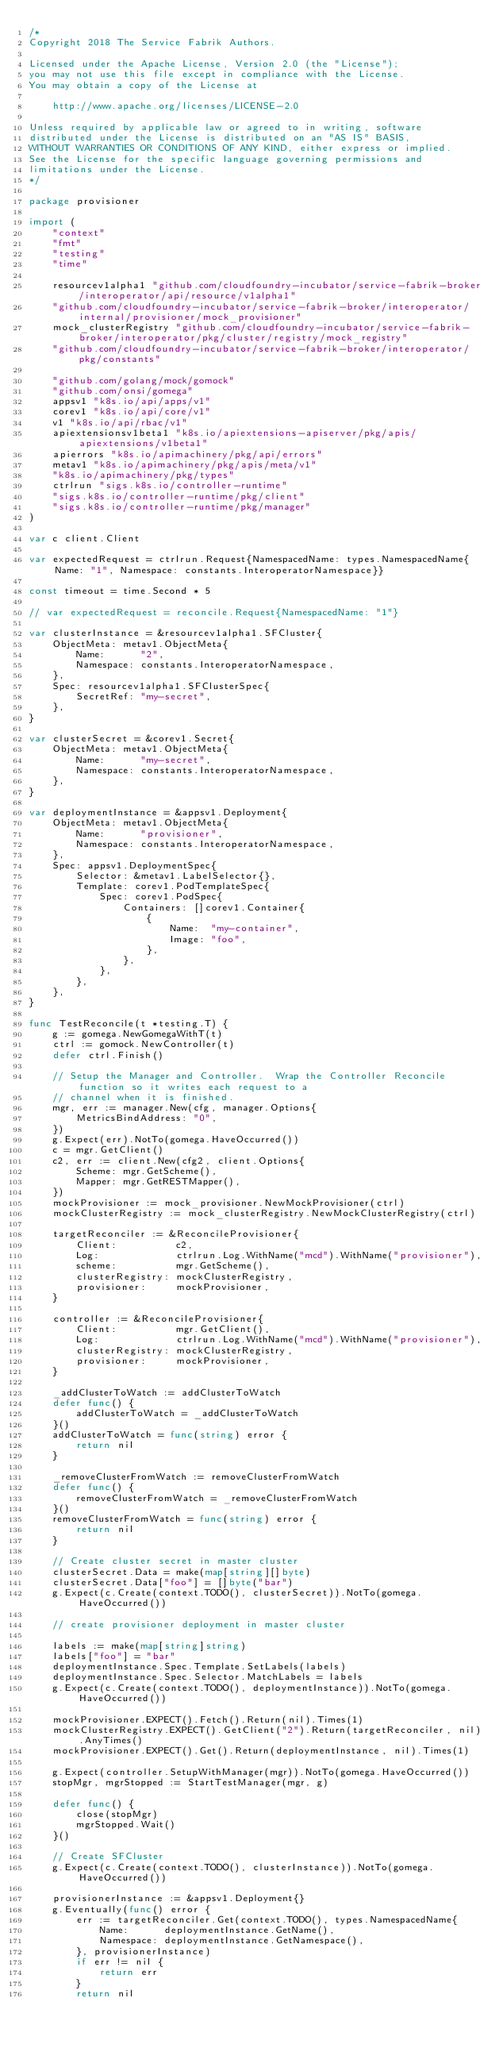<code> <loc_0><loc_0><loc_500><loc_500><_Go_>/*
Copyright 2018 The Service Fabrik Authors.

Licensed under the Apache License, Version 2.0 (the "License");
you may not use this file except in compliance with the License.
You may obtain a copy of the License at

    http://www.apache.org/licenses/LICENSE-2.0

Unless required by applicable law or agreed to in writing, software
distributed under the License is distributed on an "AS IS" BASIS,
WITHOUT WARRANTIES OR CONDITIONS OF ANY KIND, either express or implied.
See the License for the specific language governing permissions and
limitations under the License.
*/

package provisioner

import (
	"context"
	"fmt"
	"testing"
	"time"

	resourcev1alpha1 "github.com/cloudfoundry-incubator/service-fabrik-broker/interoperator/api/resource/v1alpha1"
	"github.com/cloudfoundry-incubator/service-fabrik-broker/interoperator/internal/provisioner/mock_provisioner"
	mock_clusterRegistry "github.com/cloudfoundry-incubator/service-fabrik-broker/interoperator/pkg/cluster/registry/mock_registry"
	"github.com/cloudfoundry-incubator/service-fabrik-broker/interoperator/pkg/constants"

	"github.com/golang/mock/gomock"
	"github.com/onsi/gomega"
	appsv1 "k8s.io/api/apps/v1"
	corev1 "k8s.io/api/core/v1"
	v1 "k8s.io/api/rbac/v1"
	apiextensionsv1beta1 "k8s.io/apiextensions-apiserver/pkg/apis/apiextensions/v1beta1"
	apierrors "k8s.io/apimachinery/pkg/api/errors"
	metav1 "k8s.io/apimachinery/pkg/apis/meta/v1"
	"k8s.io/apimachinery/pkg/types"
	ctrlrun "sigs.k8s.io/controller-runtime"
	"sigs.k8s.io/controller-runtime/pkg/client"
	"sigs.k8s.io/controller-runtime/pkg/manager"
)

var c client.Client

var expectedRequest = ctrlrun.Request{NamespacedName: types.NamespacedName{Name: "1", Namespace: constants.InteroperatorNamespace}}

const timeout = time.Second * 5

// var expectedRequest = reconcile.Request{NamespacedName: "1"}

var clusterInstance = &resourcev1alpha1.SFCluster{
	ObjectMeta: metav1.ObjectMeta{
		Name:      "2",
		Namespace: constants.InteroperatorNamespace,
	},
	Spec: resourcev1alpha1.SFClusterSpec{
		SecretRef: "my-secret",
	},
}

var clusterSecret = &corev1.Secret{
	ObjectMeta: metav1.ObjectMeta{
		Name:      "my-secret",
		Namespace: constants.InteroperatorNamespace,
	},
}

var deploymentInstance = &appsv1.Deployment{
	ObjectMeta: metav1.ObjectMeta{
		Name:      "provisioner",
		Namespace: constants.InteroperatorNamespace,
	},
	Spec: appsv1.DeploymentSpec{
		Selector: &metav1.LabelSelector{},
		Template: corev1.PodTemplateSpec{
			Spec: corev1.PodSpec{
				Containers: []corev1.Container{
					{
						Name:  "my-container",
						Image: "foo",
					},
				},
			},
		},
	},
}

func TestReconcile(t *testing.T) {
	g := gomega.NewGomegaWithT(t)
	ctrl := gomock.NewController(t)
	defer ctrl.Finish()

	// Setup the Manager and Controller.  Wrap the Controller Reconcile function so it writes each request to a
	// channel when it is finished.
	mgr, err := manager.New(cfg, manager.Options{
		MetricsBindAddress: "0",
	})
	g.Expect(err).NotTo(gomega.HaveOccurred())
	c = mgr.GetClient()
	c2, err := client.New(cfg2, client.Options{
		Scheme: mgr.GetScheme(),
		Mapper: mgr.GetRESTMapper(),
	})
	mockProvisioner := mock_provisioner.NewMockProvisioner(ctrl)
	mockClusterRegistry := mock_clusterRegistry.NewMockClusterRegistry(ctrl)

	targetReconciler := &ReconcileProvisioner{
		Client:          c2,
		Log:             ctrlrun.Log.WithName("mcd").WithName("provisioner"),
		scheme:          mgr.GetScheme(),
		clusterRegistry: mockClusterRegistry,
		provisioner:     mockProvisioner,
	}

	controller := &ReconcileProvisioner{
		Client:          mgr.GetClient(),
		Log:             ctrlrun.Log.WithName("mcd").WithName("provisioner"),
		clusterRegistry: mockClusterRegistry,
		provisioner:     mockProvisioner,
	}

	_addClusterToWatch := addClusterToWatch
	defer func() {
		addClusterToWatch = _addClusterToWatch
	}()
	addClusterToWatch = func(string) error {
		return nil
	}

	_removeClusterFromWatch := removeClusterFromWatch
	defer func() {
		removeClusterFromWatch = _removeClusterFromWatch
	}()
	removeClusterFromWatch = func(string) error {
		return nil
	}

	// Create cluster secret in master cluster
	clusterSecret.Data = make(map[string][]byte)
	clusterSecret.Data["foo"] = []byte("bar")
	g.Expect(c.Create(context.TODO(), clusterSecret)).NotTo(gomega.HaveOccurred())

	// create provisioner deployment in master cluster

	labels := make(map[string]string)
	labels["foo"] = "bar"
	deploymentInstance.Spec.Template.SetLabels(labels)
	deploymentInstance.Spec.Selector.MatchLabels = labels
	g.Expect(c.Create(context.TODO(), deploymentInstance)).NotTo(gomega.HaveOccurred())

	mockProvisioner.EXPECT().Fetch().Return(nil).Times(1)
	mockClusterRegistry.EXPECT().GetClient("2").Return(targetReconciler, nil).AnyTimes()
	mockProvisioner.EXPECT().Get().Return(deploymentInstance, nil).Times(1)

	g.Expect(controller.SetupWithManager(mgr)).NotTo(gomega.HaveOccurred())
	stopMgr, mgrStopped := StartTestManager(mgr, g)

	defer func() {
		close(stopMgr)
		mgrStopped.Wait()
	}()

	// Create SFCluster
	g.Expect(c.Create(context.TODO(), clusterInstance)).NotTo(gomega.HaveOccurred())

	provisionerInstance := &appsv1.Deployment{}
	g.Eventually(func() error {
		err := targetReconciler.Get(context.TODO(), types.NamespacedName{
			Name:      deploymentInstance.GetName(),
			Namespace: deploymentInstance.GetNamespace(),
		}, provisionerInstance)
		if err != nil {
			return err
		}
		return nil</code> 